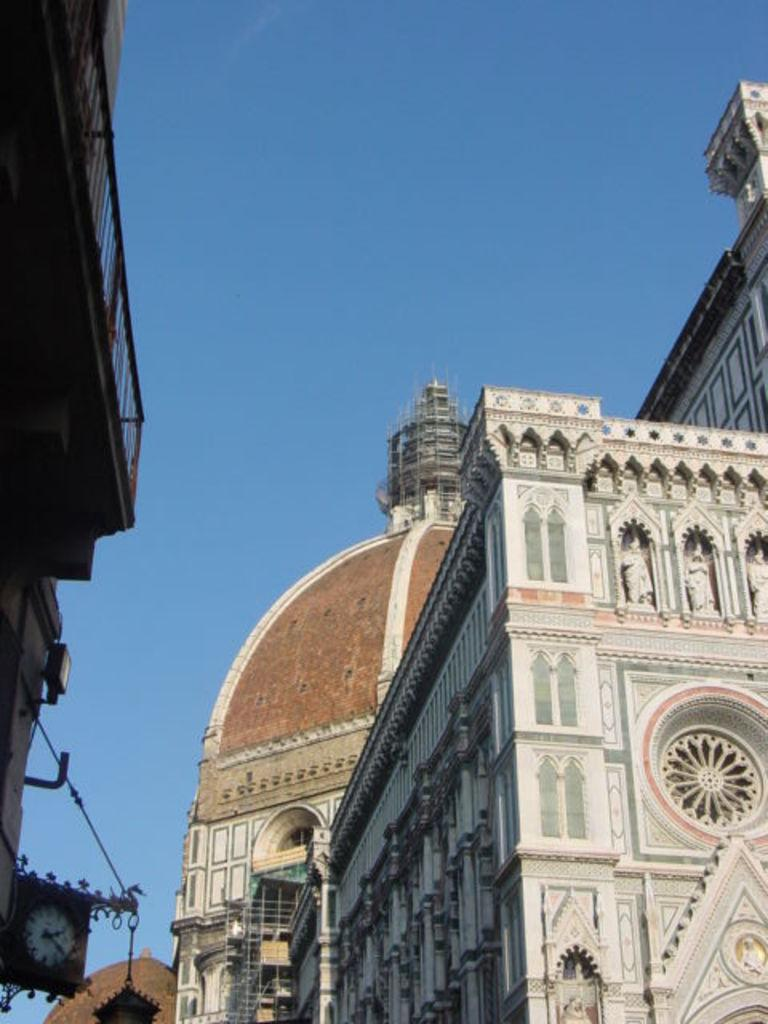What type of structures are present in the image? There are buildings in the image. What colors are the buildings? The buildings are white and brown in color. Is there any specific feature on one of the buildings? Yes, there is a clock on one of the buildings. What can be seen in the background of the image? The sky is visible in the background of the image. What type of animal can be seen holding a crayon in the image? There is no animal or crayon present in the image. How many slices of bread are visible in the image? There are no slices of bread present in the image. 